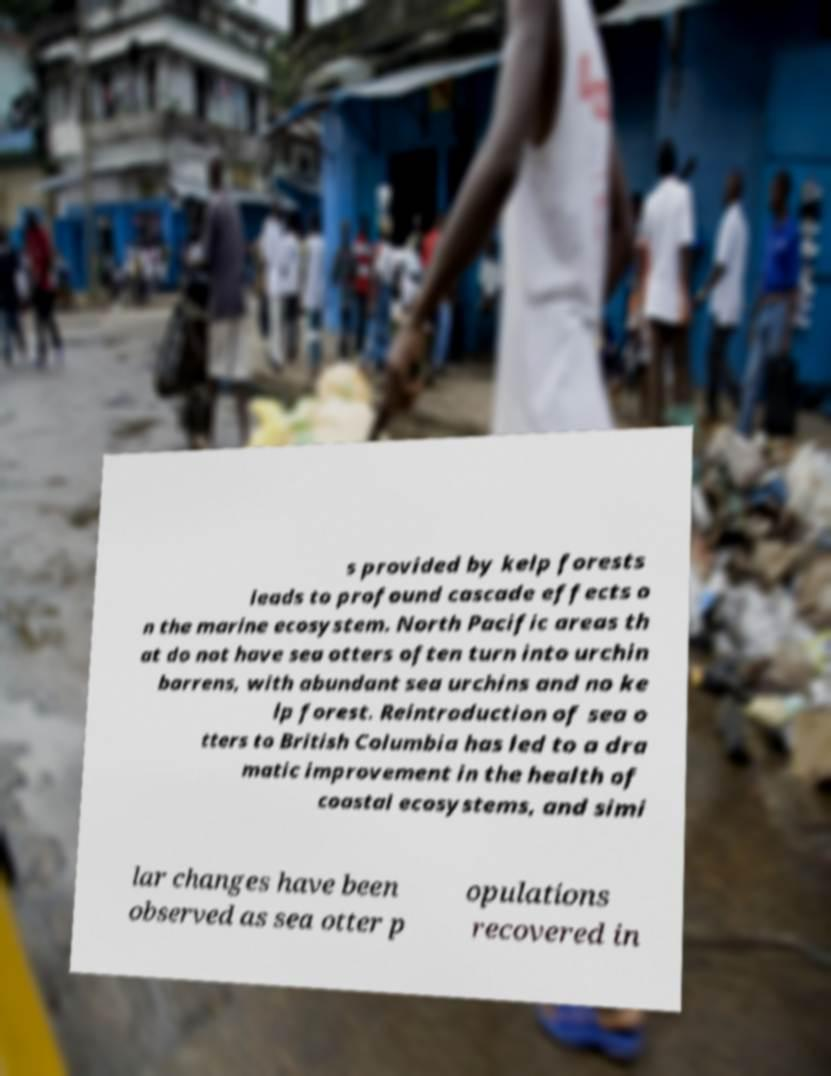For documentation purposes, I need the text within this image transcribed. Could you provide that? s provided by kelp forests leads to profound cascade effects o n the marine ecosystem. North Pacific areas th at do not have sea otters often turn into urchin barrens, with abundant sea urchins and no ke lp forest. Reintroduction of sea o tters to British Columbia has led to a dra matic improvement in the health of coastal ecosystems, and simi lar changes have been observed as sea otter p opulations recovered in 